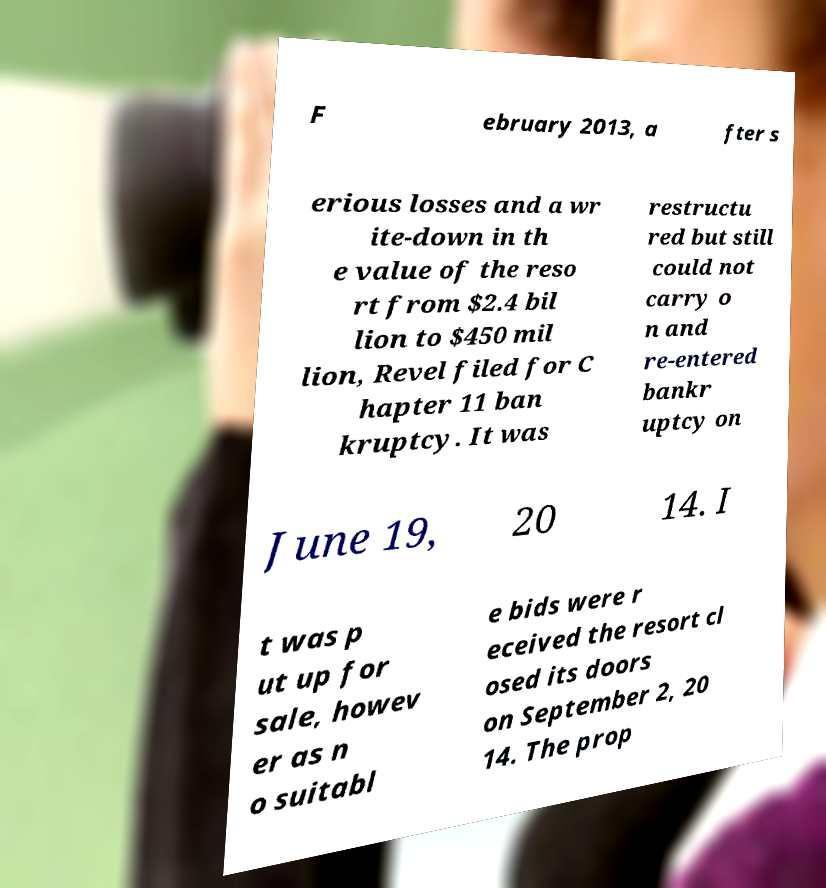Can you read and provide the text displayed in the image?This photo seems to have some interesting text. Can you extract and type it out for me? F ebruary 2013, a fter s erious losses and a wr ite-down in th e value of the reso rt from $2.4 bil lion to $450 mil lion, Revel filed for C hapter 11 ban kruptcy. It was restructu red but still could not carry o n and re-entered bankr uptcy on June 19, 20 14. I t was p ut up for sale, howev er as n o suitabl e bids were r eceived the resort cl osed its doors on September 2, 20 14. The prop 